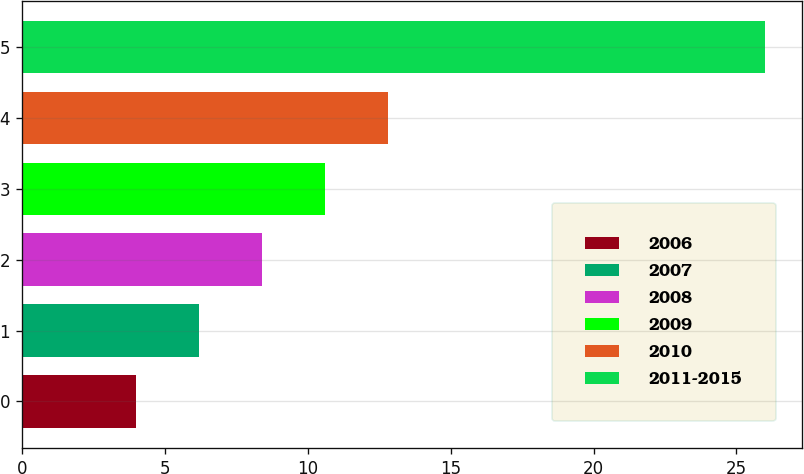Convert chart to OTSL. <chart><loc_0><loc_0><loc_500><loc_500><bar_chart><fcel>2006<fcel>2007<fcel>2008<fcel>2009<fcel>2010<fcel>2011-2015<nl><fcel>4<fcel>6.2<fcel>8.4<fcel>10.6<fcel>12.8<fcel>26<nl></chart> 